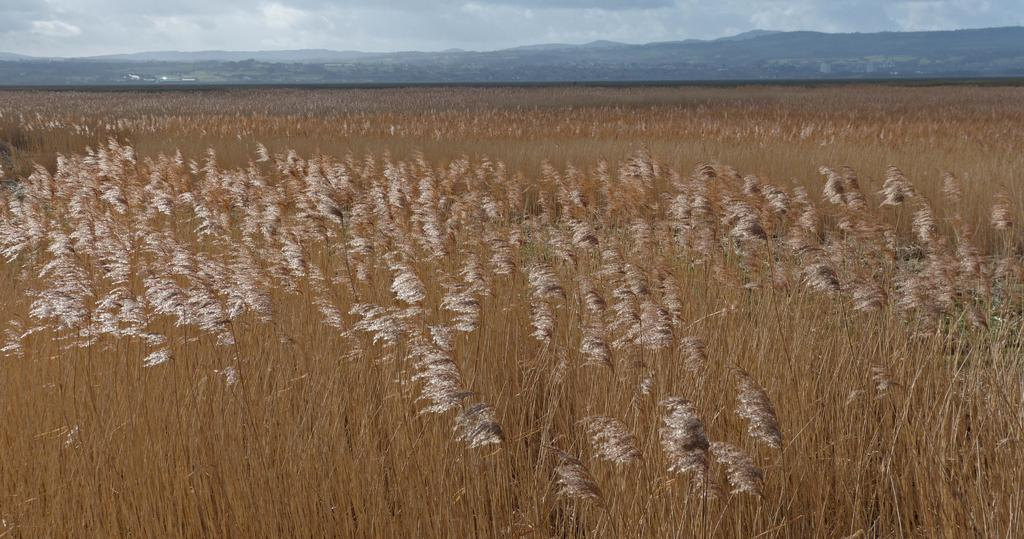What type of vegetation can be seen in the image? There is dried grass in the image. What can be seen in the distance in the image? Hills are visible in the background of the image. What else is present in the sky in the image? Clouds are present in the background of the image. What size of error can be seen in the image? There is no error present in the image; it is a photograph of a natural landscape. 